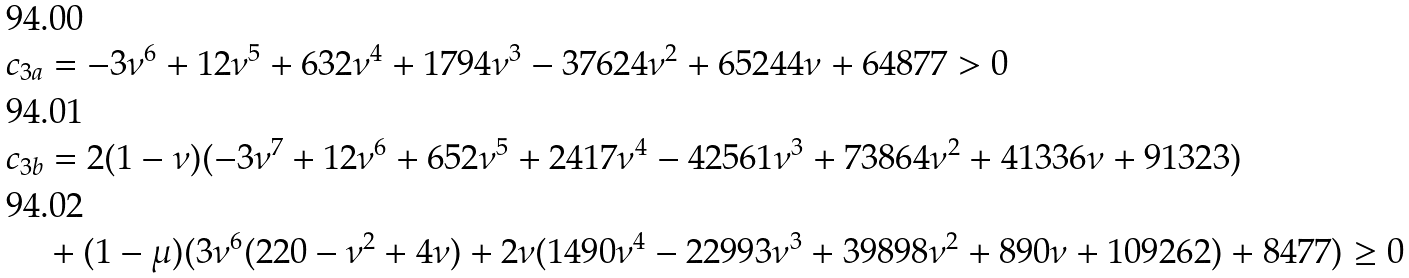Convert formula to latex. <formula><loc_0><loc_0><loc_500><loc_500>c _ { 3 a } & = - 3 \nu ^ { 6 } + 1 2 \nu ^ { 5 } + 6 3 2 \nu ^ { 4 } + 1 7 9 4 \nu ^ { 3 } - 3 7 6 2 4 \nu ^ { 2 } + 6 5 2 4 4 \nu + 6 4 8 7 7 > 0 \\ c _ { 3 b } & = 2 ( 1 - \nu ) ( - 3 \nu ^ { 7 } + 1 2 \nu ^ { 6 } + 6 5 2 \nu ^ { 5 } + 2 4 1 7 \nu ^ { 4 } - 4 2 5 6 1 \nu ^ { 3 } + 7 3 8 6 4 \nu ^ { 2 } + 4 1 3 3 6 \nu + 9 1 3 2 3 ) \\ & + ( 1 - \mu ) ( 3 \nu ^ { 6 } ( 2 2 0 - \nu ^ { 2 } + 4 \nu ) + 2 \nu ( 1 4 9 0 \nu ^ { 4 } - 2 2 9 9 3 \nu ^ { 3 } + 3 9 8 9 8 \nu ^ { 2 } + 8 9 0 \nu + 1 0 9 2 6 2 ) + 8 4 7 7 ) \geq 0</formula> 